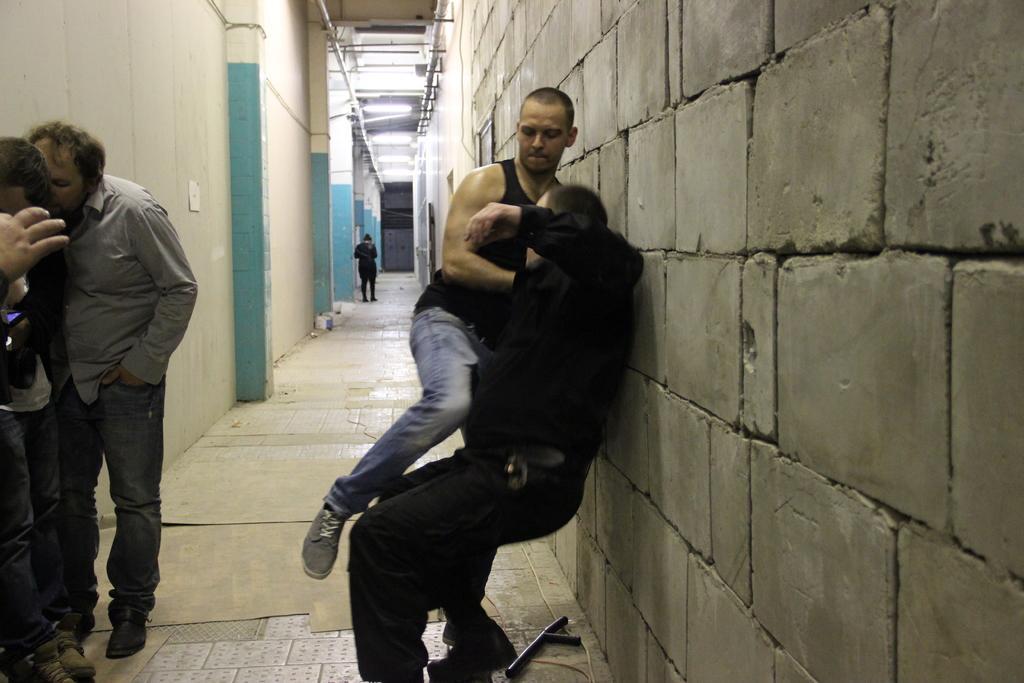In one or two sentences, can you explain what this image depicts? In this picture we can see the group of people seems to be standing on the ground. On the right we can see the two persons seems to be fighting with each other and there are some objects lying on the ground. In the background we can see the metal rods, roof, lights and some other objects. 